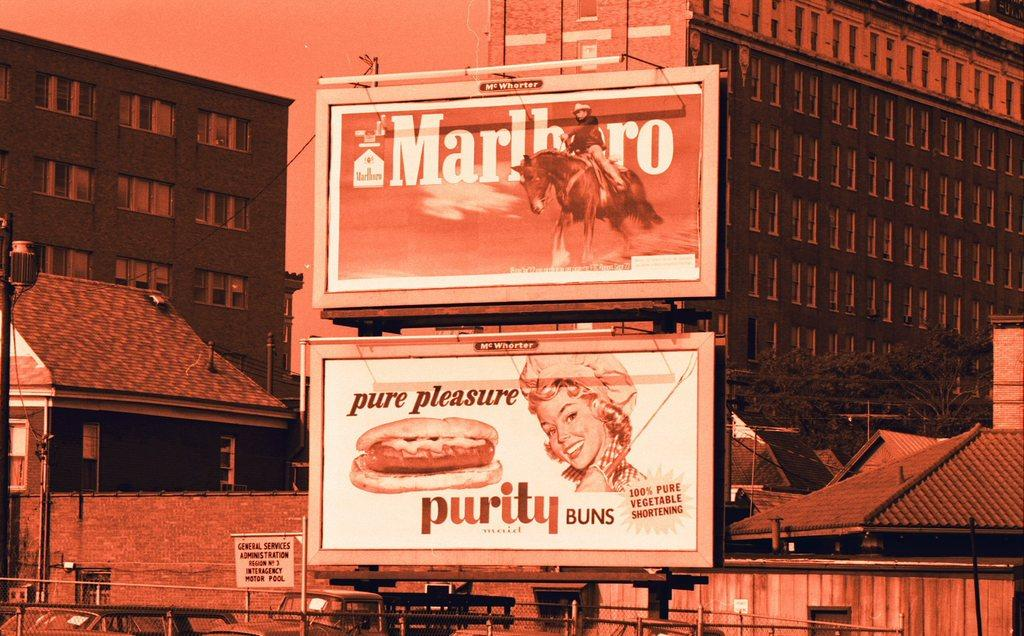Provide a one-sentence caption for the provided image. The billboards advertise Marlboro cigarettes and Purity buns. 